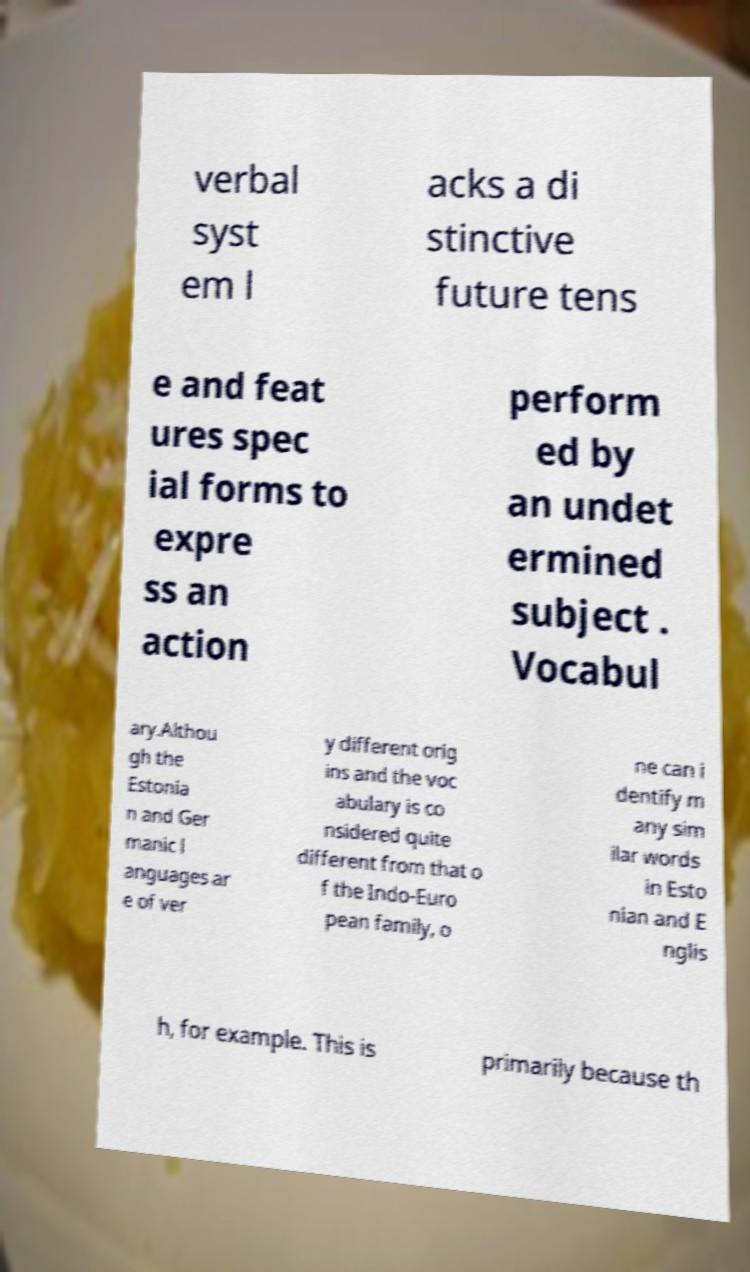For documentation purposes, I need the text within this image transcribed. Could you provide that? verbal syst em l acks a di stinctive future tens e and feat ures spec ial forms to expre ss an action perform ed by an undet ermined subject . Vocabul ary.Althou gh the Estonia n and Ger manic l anguages ar e of ver y different orig ins and the voc abulary is co nsidered quite different from that o f the Indo-Euro pean family, o ne can i dentify m any sim ilar words in Esto nian and E nglis h, for example. This is primarily because th 